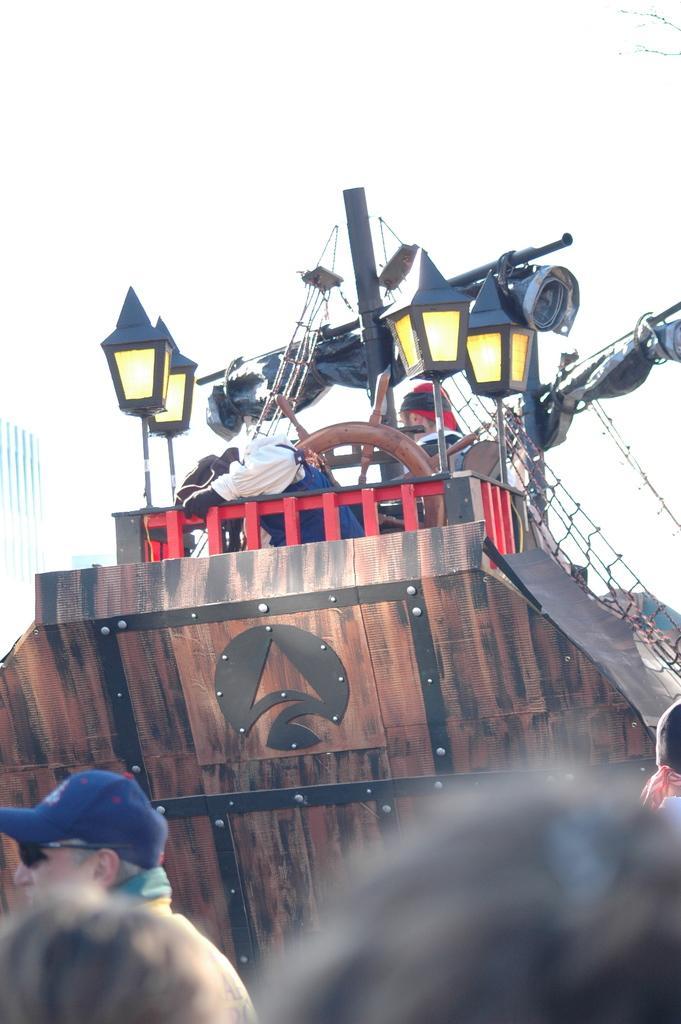Can you describe this image briefly? In this image we can see a few people, there is a ship, in the ship we can see there are some lights, poles, persons and net. 